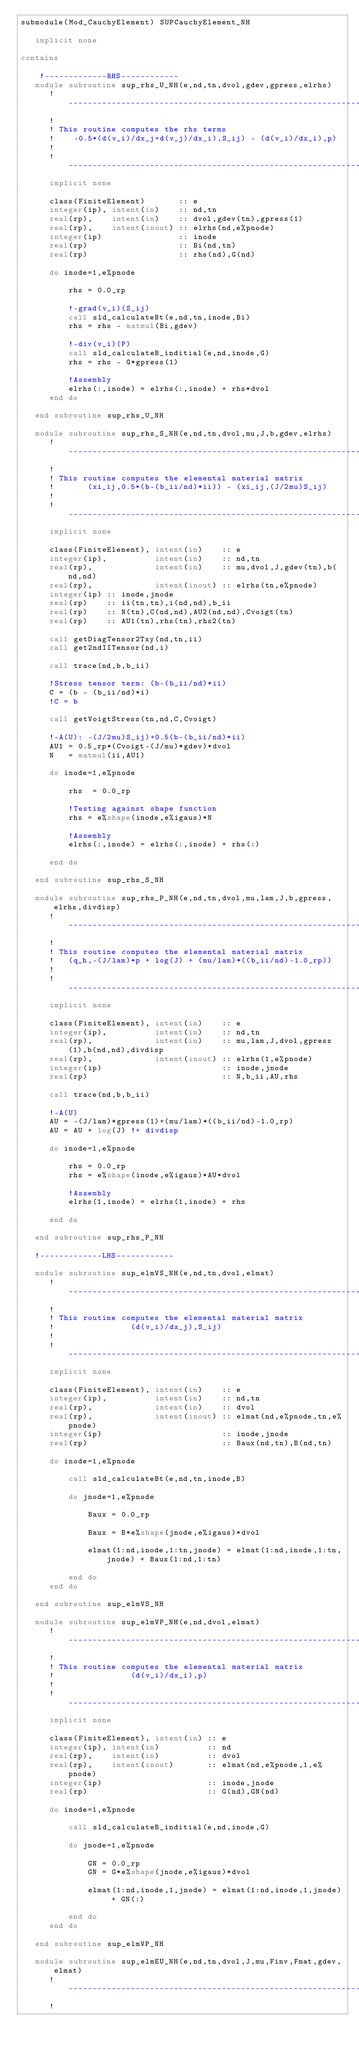Convert code to text. <code><loc_0><loc_0><loc_500><loc_500><_FORTRAN_>submodule(Mod_CauchyElement) SUPCauchyElement_NH

   implicit none

contains

    !-------------RHS------------
   module subroutine sup_rhs_U_NH(e,nd,tn,dvol,gdev,gpress,elrhs)
      !-----------------------------------------------------------------------
      !
      ! This routine computes the rhs terms 
      !    -0.5*(d(v_i)/dx_j+d(v_j)/dx_i),S_ij) - (d(v_i)/dx_i),p)
      !
      !-----------------------------------------------------------------------
      implicit none

      class(FiniteElement)       :: e
      integer(ip), intent(in)    :: nd,tn
      real(rp),    intent(in)    :: dvol,gdev(tn),gpress(1)
      real(rp),    intent(inout) :: elrhs(nd,e%pnode)
      integer(ip)                :: inode
      real(rp)                   :: Bi(nd,tn)
      real(rp)                   :: rhs(nd),G(nd)

      do inode=1,e%pnode

          rhs = 0.0_rp

          !-grad(v_i)(S_ij)
          call sld_calculateBt(e,nd,tn,inode,Bi)
          rhs = rhs - matmul(Bi,gdev)

          !-div(v_i)(P)
          call sld_calculateB_inditial(e,nd,inode,G)
          rhs = rhs - G*gpress(1)

          !Assembly
          elrhs(:,inode) = elrhs(:,inode) + rhs*dvol
      end do

   end subroutine sup_rhs_U_NH

   module subroutine sup_rhs_S_NH(e,nd,tn,dvol,mu,J,b,gdev,elrhs)
      !-----------------------------------------------------------------------
      !
      ! This routine computes the elemental material matrix 
      !       (xi_ij,0.5*(b-(b_ii/nd)*ii)) - (xi_ij,(J/2mu)S_ij)
      !
      !-----------------------------------------------------------------------
      implicit none

      class(FiniteElement), intent(in)    :: e
      integer(ip),          intent(in)    :: nd,tn
      real(rp),             intent(in)    :: mu,dvol,J,gdev(tn),b(nd,nd)
      real(rp),             intent(inout) :: elrhs(tn,e%pnode)
      integer(ip) :: inode,jnode
      real(rp)    :: ii(tn,tn),i(nd,nd),b_ii
      real(rp)    :: N(tn),C(nd,nd),AU2(nd,nd),Cvoigt(tn)
      real(rp)    :: AU1(tn),rhs(tn),rhs2(tn)

      call getDiagTensor2Txy(nd,tn,ii)
      call get2ndIITensor(nd,i)

      call trace(nd,b,b_ii)

      !Stress tensor term: (b-(b_ii/nd)*ii)
      C = (b - (b_ii/nd)*i)
      !C = b

      call getVoigtStress(tn,nd,C,Cvoigt)

      !-A(U): -(J/2mu)S_ij)+0.5(b-(b_ii/nd)*ii)
      AU1 = 0.5_rp*(Cvoigt-(J/mu)*gdev)*dvol
      N   = matmul(ii,AU1)

      do inode=1,e%pnode

          rhs  = 0.0_rp

          !Testing against shape function
          rhs = e%shape(inode,e%igaus)*N

          !Assembly
          elrhs(:,inode) = elrhs(:,inode) + rhs(:)

      end do

   end subroutine sup_rhs_S_NH

   module subroutine sup_rhs_P_NH(e,nd,tn,dvol,mu,lam,J,b,gpress,elrhs,divdisp)
      !-----------------------------------------------------------------------
      !
      ! This routine computes the elemental material matrix 
      !   (q_h,-(J/lam)*p + log(J) + (mu/lam)*((b_ii/nd)-1.0_rp))
      !
      !-----------------------------------------------------------------------
      implicit none

      class(FiniteElement), intent(in)    :: e
      integer(ip),          intent(in)    :: nd,tn
      real(rp),             intent(in)    :: mu,lam,J,dvol,gpress(1),b(nd,nd),divdisp
      real(rp),             intent(inout) :: elrhs(1,e%pnode)
      integer(ip)                         :: inode,jnode
      real(rp)                            :: N,b_ii,AU,rhs

      call trace(nd,b,b_ii)

      !-A(U)
      AU = -(J/lam)*gpress(1)+(mu/lam)*((b_ii/nd)-1.0_rp)
      AU = AU + log(J) !+ divdisp

      do inode=1,e%pnode

          rhs = 0.0_rp
          rhs = e%shape(inode,e%igaus)*AU*dvol

          !Assembly
          elrhs(1,inode) = elrhs(1,inode) + rhs

      end do

   end subroutine sup_rhs_P_NH

   !-------------LHS------------

   module subroutine sup_elmVS_NH(e,nd,tn,dvol,elmat)
      !-----------------------------------------------------------------------
      !
      ! This routine computes the elemental material matrix 
      !                (d(v_i)/dx_j),S_ij) 
      !
      !-----------------------------------------------------------------------
      implicit none

      class(FiniteElement), intent(in)    :: e
      integer(ip),          intent(in)    :: nd,tn
      real(rp),             intent(in)    :: dvol
      real(rp),             intent(inout) :: elmat(nd,e%pnode,tn,e%pnode)
      integer(ip)                         :: inode,jnode
      real(rp)                            :: Baux(nd,tn),B(nd,tn)

      do inode=1,e%pnode

          call sld_calculateBt(e,nd,tn,inode,B)

          do jnode=1,e%pnode

              Baux = 0.0_rp

              Baux = B*e%shape(jnode,e%igaus)*dvol

              elmat(1:nd,inode,1:tn,jnode) = elmat(1:nd,inode,1:tn,jnode) + Baux(1:nd,1:tn)

          end do
      end do

   end subroutine sup_elmVS_NH

   module subroutine sup_elmVP_NH(e,nd,dvol,elmat)
      !-----------------------------------------------------------------------
      !
      ! This routine computes the elemental material matrix 
      !                (d(v_i)/dx_i),p) 
      !
      !-----------------------------------------------------------------------
      implicit none

      class(FiniteElement), intent(in) :: e
      integer(ip), intent(in)          :: nd
      real(rp),    intent(in)          :: dvol
      real(rp),    intent(inout)       :: elmat(nd,e%pnode,1,e%pnode)
      integer(ip)                      :: inode,jnode
      real(rp)                         :: G(nd),GN(nd)

      do inode=1,e%pnode

          call sld_calculateB_inditial(e,nd,inode,G)

          do jnode=1,e%pnode

              GN = 0.0_rp
              GN = G*e%shape(jnode,e%igaus)*dvol

              elmat(1:nd,inode,1,jnode) = elmat(1:nd,inode,1,jnode) + GN(:)

          end do
      end do

   end subroutine sup_elmVP_NH

   module subroutine sup_elmEU_NH(e,nd,tn,dvol,J,mu,Finv,Fmat,gdev,elmat)
      !-----------------------------------------------------------------------
      !</code> 